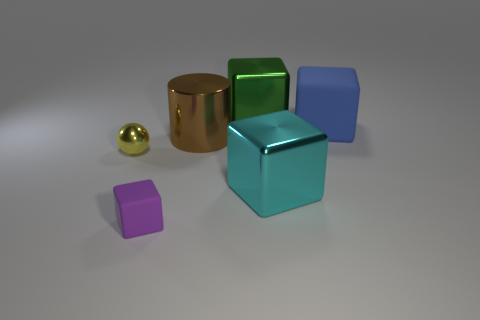Add 2 large brown cylinders. How many objects exist? 8 Subtract all cylinders. How many objects are left? 5 Add 2 brown metallic cylinders. How many brown metallic cylinders are left? 3 Add 3 metal balls. How many metal balls exist? 4 Subtract 0 purple spheres. How many objects are left? 6 Subtract all purple matte cylinders. Subtract all big blue things. How many objects are left? 5 